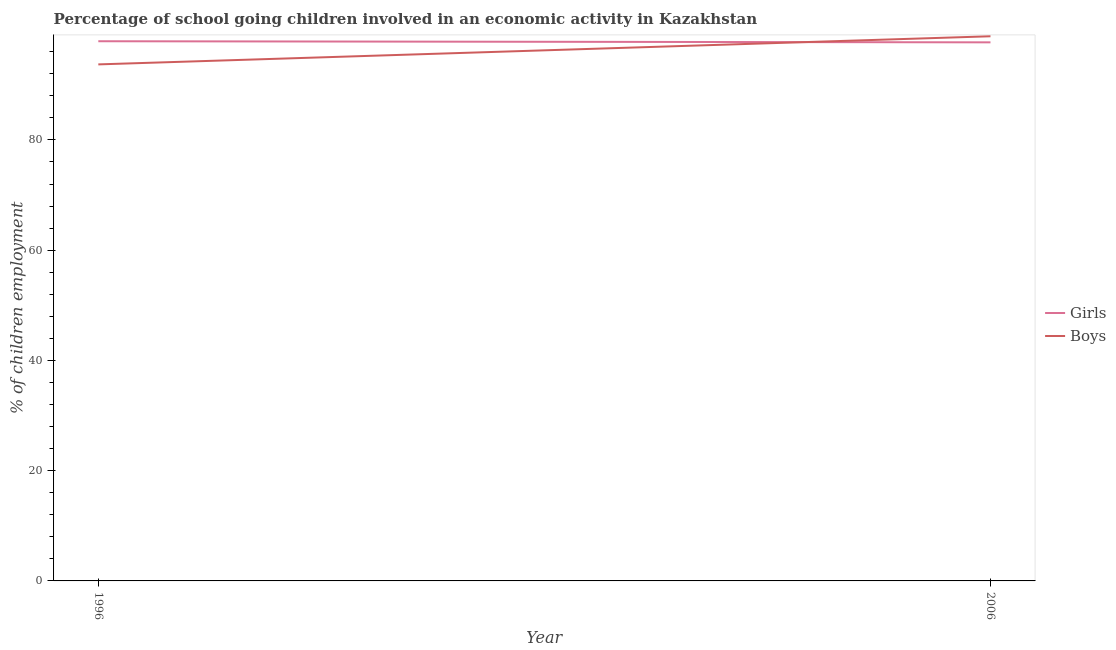What is the percentage of school going boys in 2006?
Offer a terse response. 98.8. Across all years, what is the maximum percentage of school going girls?
Your answer should be compact. 97.9. Across all years, what is the minimum percentage of school going boys?
Provide a short and direct response. 93.7. What is the total percentage of school going girls in the graph?
Your response must be concise. 195.6. What is the difference between the percentage of school going girls in 1996 and that in 2006?
Your answer should be very brief. 0.2. What is the difference between the percentage of school going boys in 1996 and the percentage of school going girls in 2006?
Your answer should be compact. -4. What is the average percentage of school going boys per year?
Provide a short and direct response. 96.25. In the year 2006, what is the difference between the percentage of school going girls and percentage of school going boys?
Your answer should be compact. -1.1. What is the ratio of the percentage of school going girls in 1996 to that in 2006?
Make the answer very short. 1. Is the percentage of school going girls in 1996 less than that in 2006?
Offer a terse response. No. Is the percentage of school going boys strictly greater than the percentage of school going girls over the years?
Keep it short and to the point. No. How many lines are there?
Your response must be concise. 2. How many years are there in the graph?
Offer a terse response. 2. Are the values on the major ticks of Y-axis written in scientific E-notation?
Ensure brevity in your answer.  No. Does the graph contain any zero values?
Keep it short and to the point. No. Where does the legend appear in the graph?
Give a very brief answer. Center right. How are the legend labels stacked?
Keep it short and to the point. Vertical. What is the title of the graph?
Ensure brevity in your answer.  Percentage of school going children involved in an economic activity in Kazakhstan. What is the label or title of the Y-axis?
Offer a very short reply. % of children employment. What is the % of children employment of Girls in 1996?
Ensure brevity in your answer.  97.9. What is the % of children employment of Boys in 1996?
Your answer should be very brief. 93.7. What is the % of children employment in Girls in 2006?
Ensure brevity in your answer.  97.7. What is the % of children employment in Boys in 2006?
Offer a very short reply. 98.8. Across all years, what is the maximum % of children employment in Girls?
Give a very brief answer. 97.9. Across all years, what is the maximum % of children employment of Boys?
Your answer should be compact. 98.8. Across all years, what is the minimum % of children employment in Girls?
Keep it short and to the point. 97.7. Across all years, what is the minimum % of children employment of Boys?
Offer a terse response. 93.7. What is the total % of children employment of Girls in the graph?
Offer a very short reply. 195.6. What is the total % of children employment in Boys in the graph?
Keep it short and to the point. 192.5. What is the difference between the % of children employment in Girls in 1996 and that in 2006?
Make the answer very short. 0.2. What is the difference between the % of children employment in Girls in 1996 and the % of children employment in Boys in 2006?
Provide a succinct answer. -0.9. What is the average % of children employment of Girls per year?
Your answer should be compact. 97.8. What is the average % of children employment of Boys per year?
Ensure brevity in your answer.  96.25. In the year 1996, what is the difference between the % of children employment in Girls and % of children employment in Boys?
Provide a short and direct response. 4.2. What is the ratio of the % of children employment in Boys in 1996 to that in 2006?
Ensure brevity in your answer.  0.95. What is the difference between the highest and the lowest % of children employment of Boys?
Your answer should be compact. 5.1. 